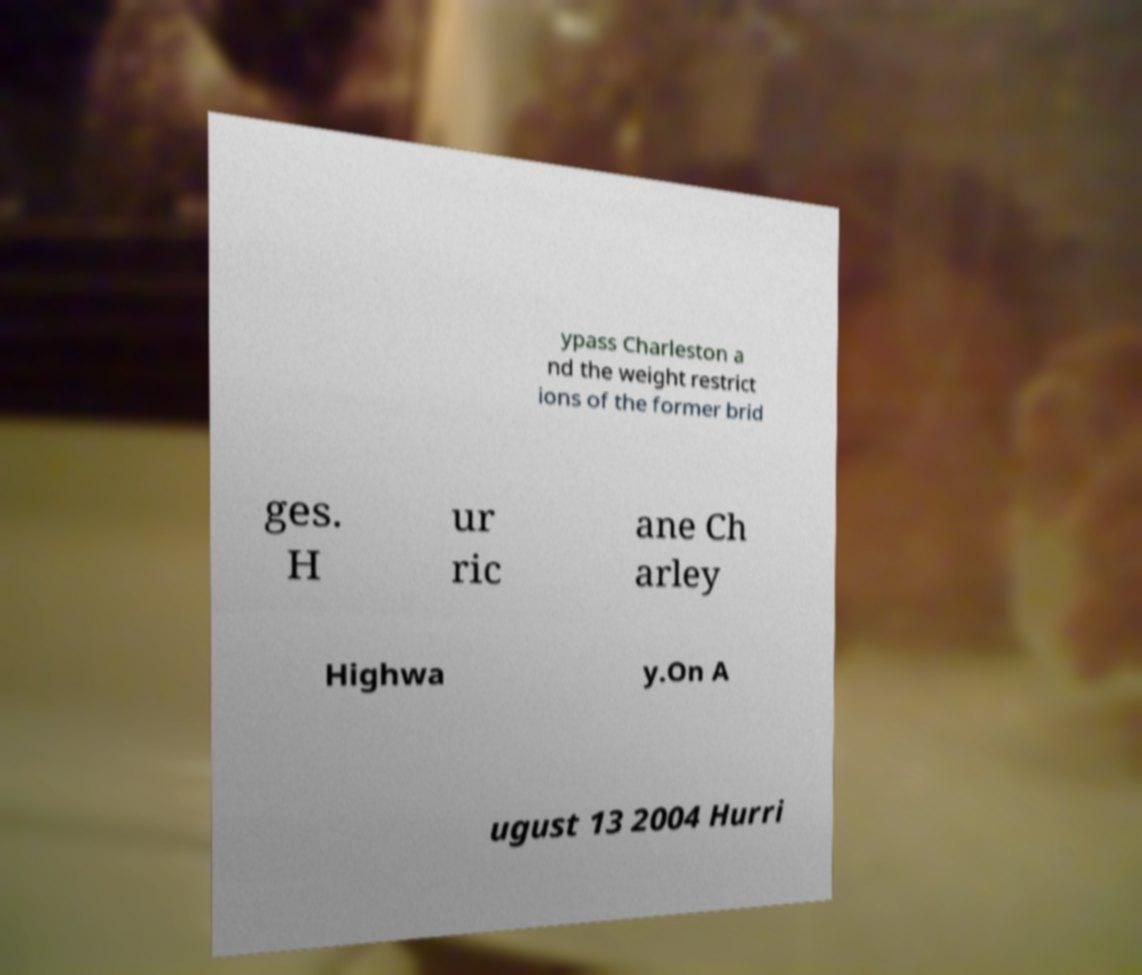Can you read and provide the text displayed in the image?This photo seems to have some interesting text. Can you extract and type it out for me? ypass Charleston a nd the weight restrict ions of the former brid ges. H ur ric ane Ch arley Highwa y.On A ugust 13 2004 Hurri 